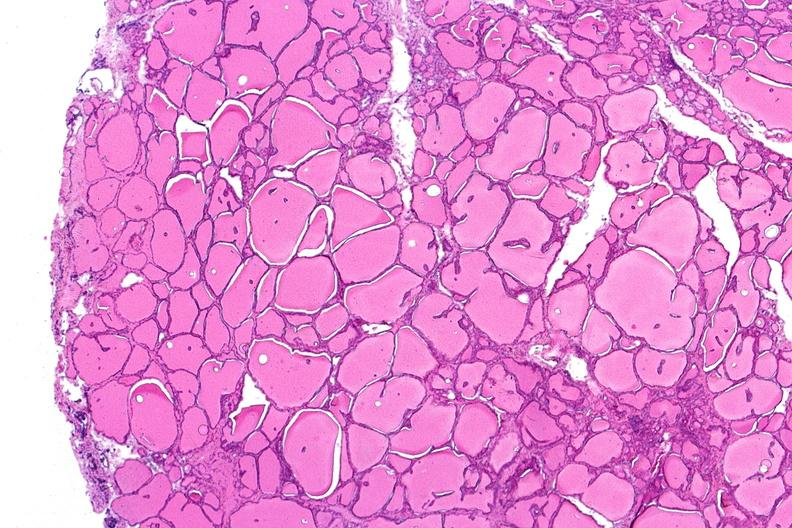s hemorrhage in newborn present?
Answer the question using a single word or phrase. No 